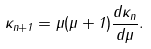Convert formula to latex. <formula><loc_0><loc_0><loc_500><loc_500>\kappa _ { n + 1 } = \mu ( \mu + 1 ) { \frac { d \kappa _ { n } } { d \mu } } .</formula> 